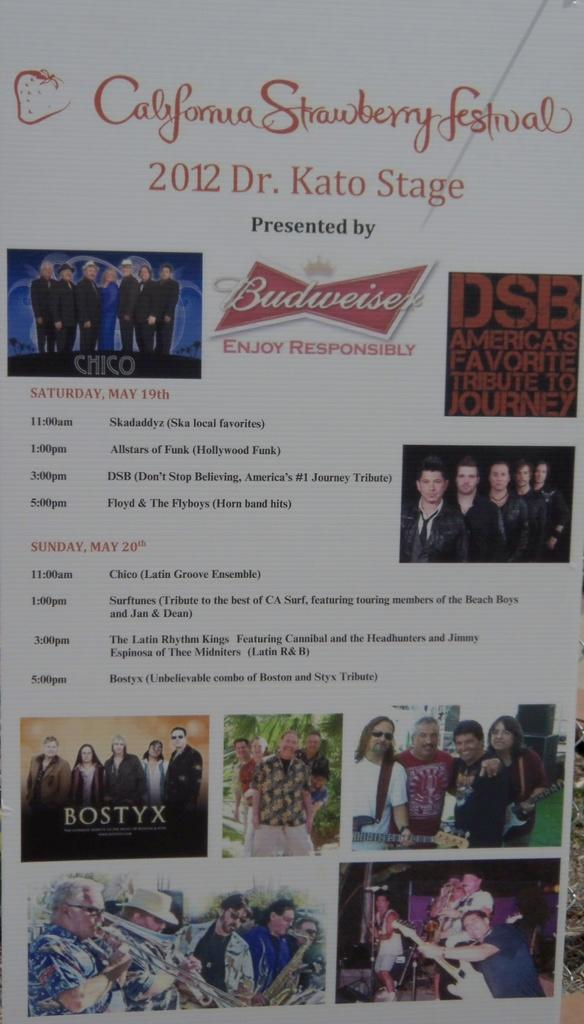<image>
Describe the image concisely. A calendar of events for the California Strawberry Festival from 2012 on Dr. Kato Stage. 